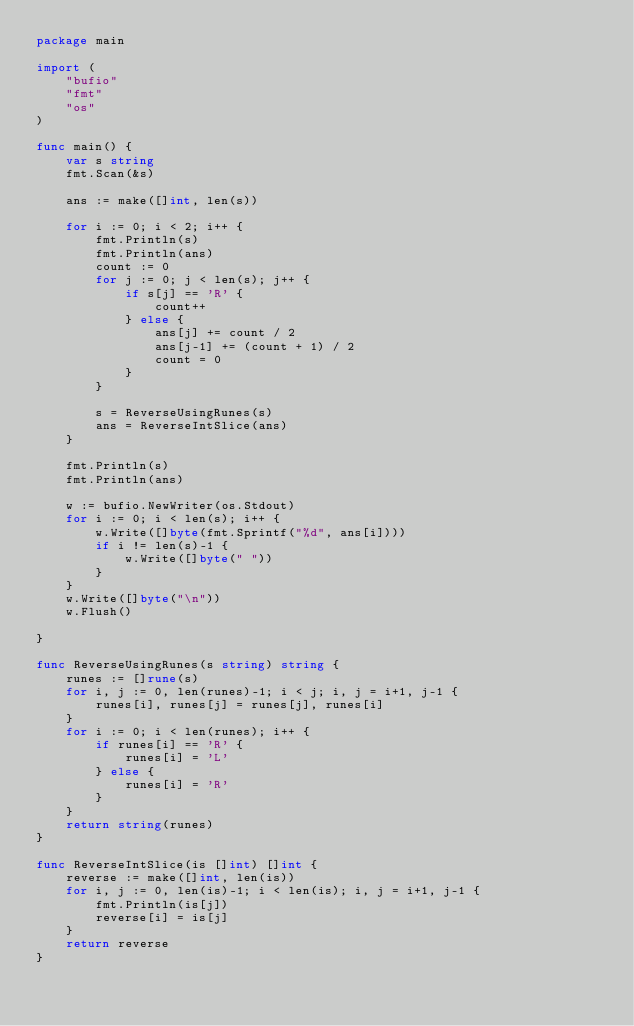Convert code to text. <code><loc_0><loc_0><loc_500><loc_500><_Go_>package main

import (
	"bufio"
	"fmt"
	"os"
)

func main() {
	var s string
	fmt.Scan(&s)

	ans := make([]int, len(s))

	for i := 0; i < 2; i++ {
		fmt.Println(s)
		fmt.Println(ans)
		count := 0
		for j := 0; j < len(s); j++ {
			if s[j] == 'R' {
				count++
			} else {
				ans[j] += count / 2
				ans[j-1] += (count + 1) / 2
				count = 0
			}
		}

		s = ReverseUsingRunes(s)
		ans = ReverseIntSlice(ans)
	}

	fmt.Println(s)
	fmt.Println(ans)

	w := bufio.NewWriter(os.Stdout)
	for i := 0; i < len(s); i++ {
		w.Write([]byte(fmt.Sprintf("%d", ans[i])))
		if i != len(s)-1 {
			w.Write([]byte(" "))
		}
	}
	w.Write([]byte("\n"))
	w.Flush()

}

func ReverseUsingRunes(s string) string {
	runes := []rune(s)
	for i, j := 0, len(runes)-1; i < j; i, j = i+1, j-1 {
		runes[i], runes[j] = runes[j], runes[i]
	}
	for i := 0; i < len(runes); i++ {
		if runes[i] == 'R' {
			runes[i] = 'L'
		} else {
			runes[i] = 'R'
		}
	}
	return string(runes)
}

func ReverseIntSlice(is []int) []int {
	reverse := make([]int, len(is))
	for i, j := 0, len(is)-1; i < len(is); i, j = i+1, j-1 {
		fmt.Println(is[j])
		reverse[i] = is[j]
	}
	return reverse
}
</code> 